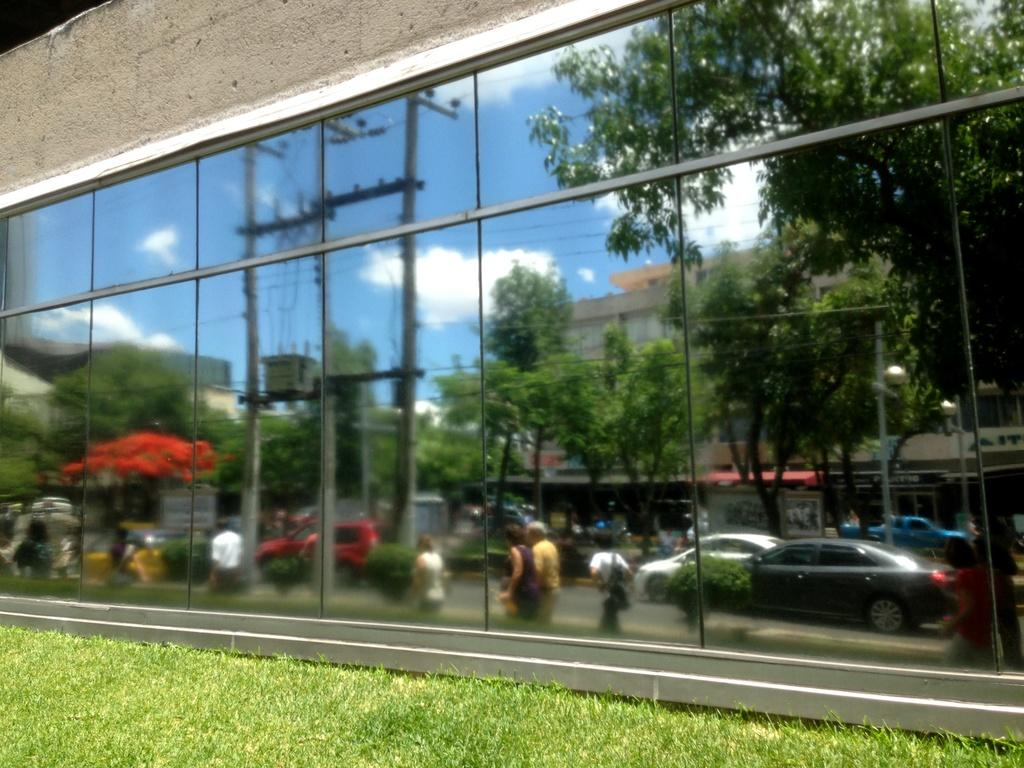What type of vegetation can be seen in the image? There are trees and grass in the image. What type of man-made structures are present in the image? There are buildings in the image. What mode of transportation can be seen in the image? There are cars in the image. What are the people in the image doing? People are walking in the image. What is the tall, vertical object in the image? There is a pole in the image. What part of the natural environment is visible in the image? The sky is visible in the image. What type of current can be seen flowing through the image? There is no current visible in the image; it is a still image featuring trees, cars, buildings, people walking, a pole, and the sky. What song is being played in the background of the image? There is no audio or song present in the image, as it is a still photograph. 